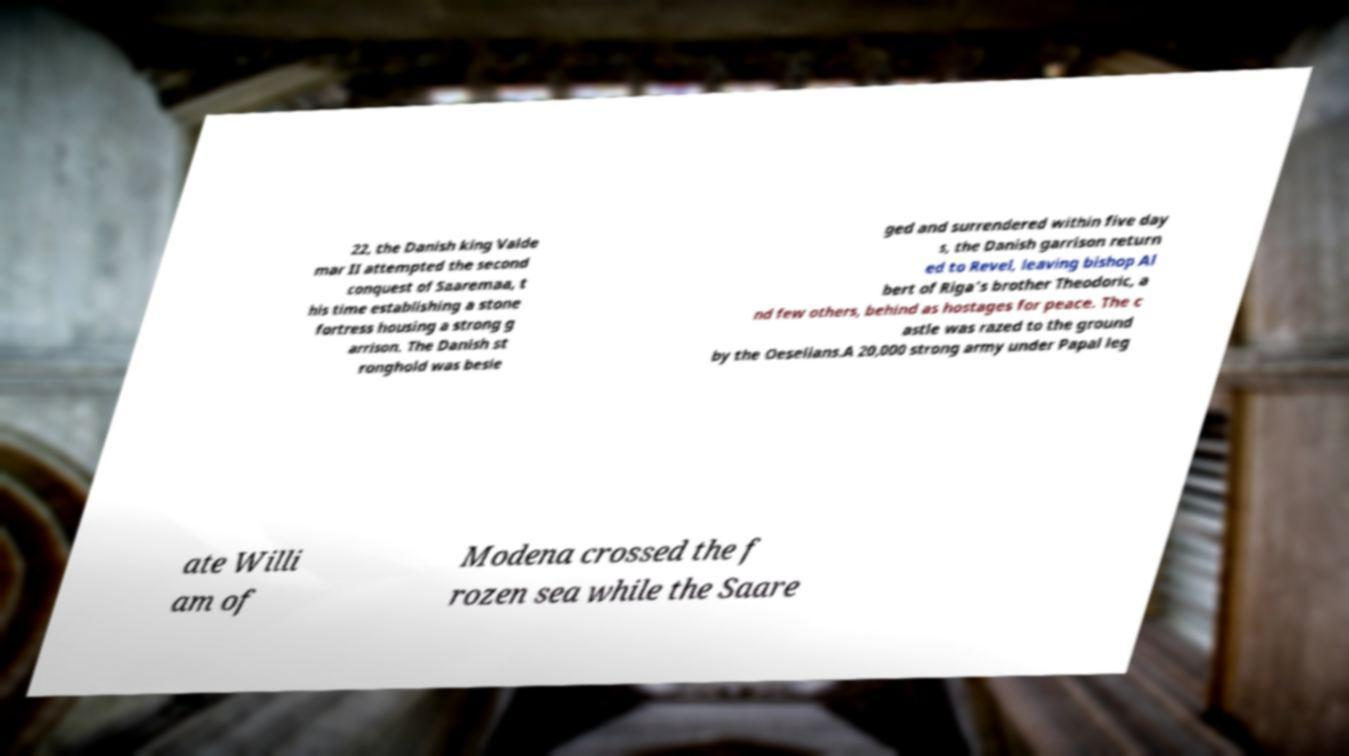Can you read and provide the text displayed in the image?This photo seems to have some interesting text. Can you extract and type it out for me? 22, the Danish king Valde mar II attempted the second conquest of Saaremaa, t his time establishing a stone fortress housing a strong g arrison. The Danish st ronghold was besie ged and surrendered within five day s, the Danish garrison return ed to Revel, leaving bishop Al bert of Riga's brother Theodoric, a nd few others, behind as hostages for peace. The c astle was razed to the ground by the Oeselians.A 20,000 strong army under Papal leg ate Willi am of Modena crossed the f rozen sea while the Saare 